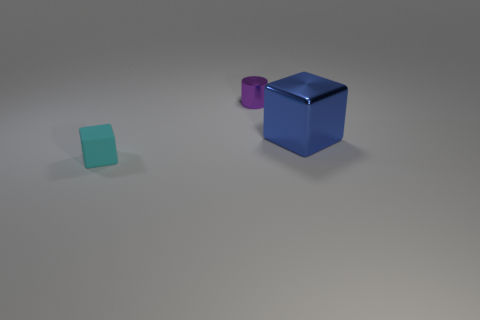What is the shape of the cyan object that is the same size as the purple metal thing?
Provide a succinct answer. Cube. There is a cube in front of the blue cube; is it the same size as the shiny thing that is on the right side of the purple thing?
Give a very brief answer. No. There is a purple object that is the same material as the blue thing; what shape is it?
Ensure brevity in your answer.  Cylinder. What material is the cyan thing that is the same shape as the large blue metallic object?
Ensure brevity in your answer.  Rubber. What is the size of the cube that is right of the small object that is behind the cube that is to the left of the tiny purple metallic object?
Your response must be concise. Large. Is the size of the shiny block the same as the shiny cylinder?
Your response must be concise. No. Do the thing that is on the right side of the purple cylinder and the small thing left of the small purple cylinder have the same shape?
Your answer should be compact. Yes. Is the number of big metallic objects left of the blue metallic thing the same as the number of small green spheres?
Offer a very short reply. Yes. There is a block that is behind the small cyan matte block; are there any cyan cubes that are to the left of it?
Offer a very short reply. Yes. Do the block on the left side of the purple cylinder and the large blue thing have the same material?
Provide a short and direct response. No. 